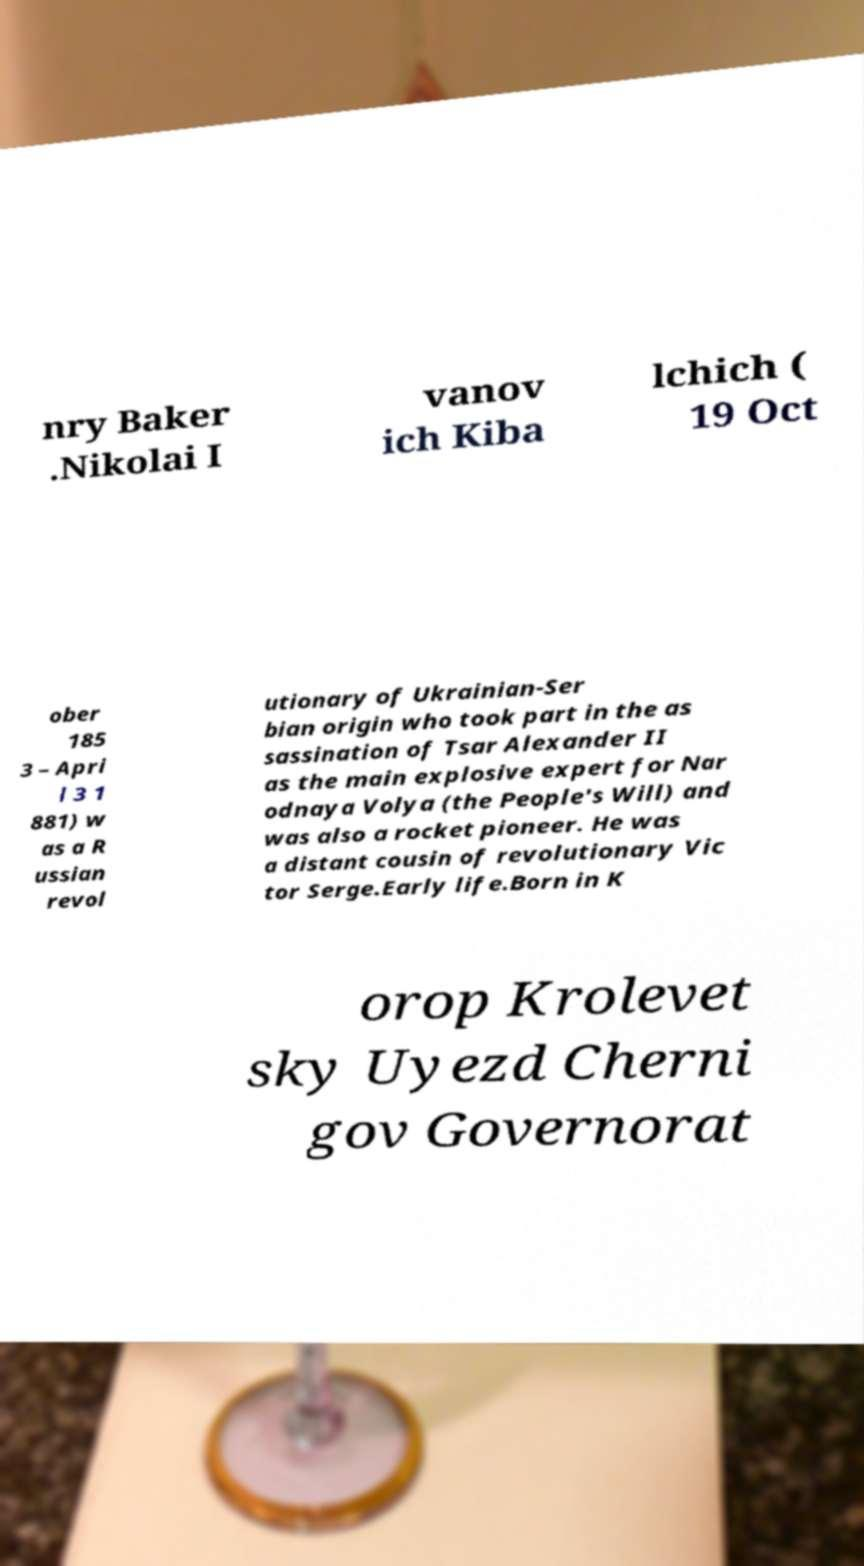For documentation purposes, I need the text within this image transcribed. Could you provide that? nry Baker .Nikolai I vanov ich Kiba lchich ( 19 Oct ober 185 3 – Apri l 3 1 881) w as a R ussian revol utionary of Ukrainian-Ser bian origin who took part in the as sassination of Tsar Alexander II as the main explosive expert for Nar odnaya Volya (the People's Will) and was also a rocket pioneer. He was a distant cousin of revolutionary Vic tor Serge.Early life.Born in K orop Krolevet sky Uyezd Cherni gov Governorat 